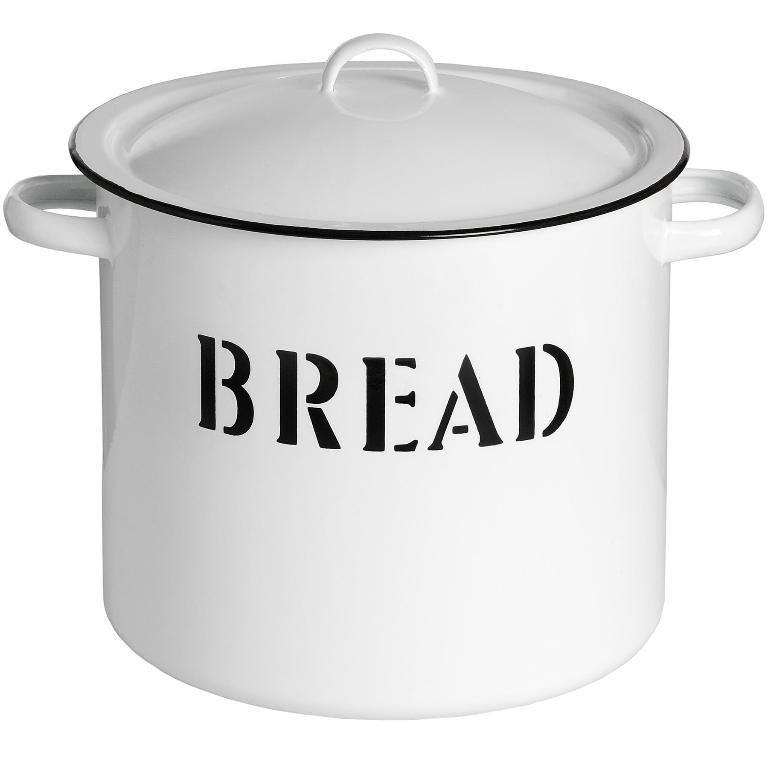<image>
Offer a succinct explanation of the picture presented. A white pot with a lid has bread spelled out in black letters. 